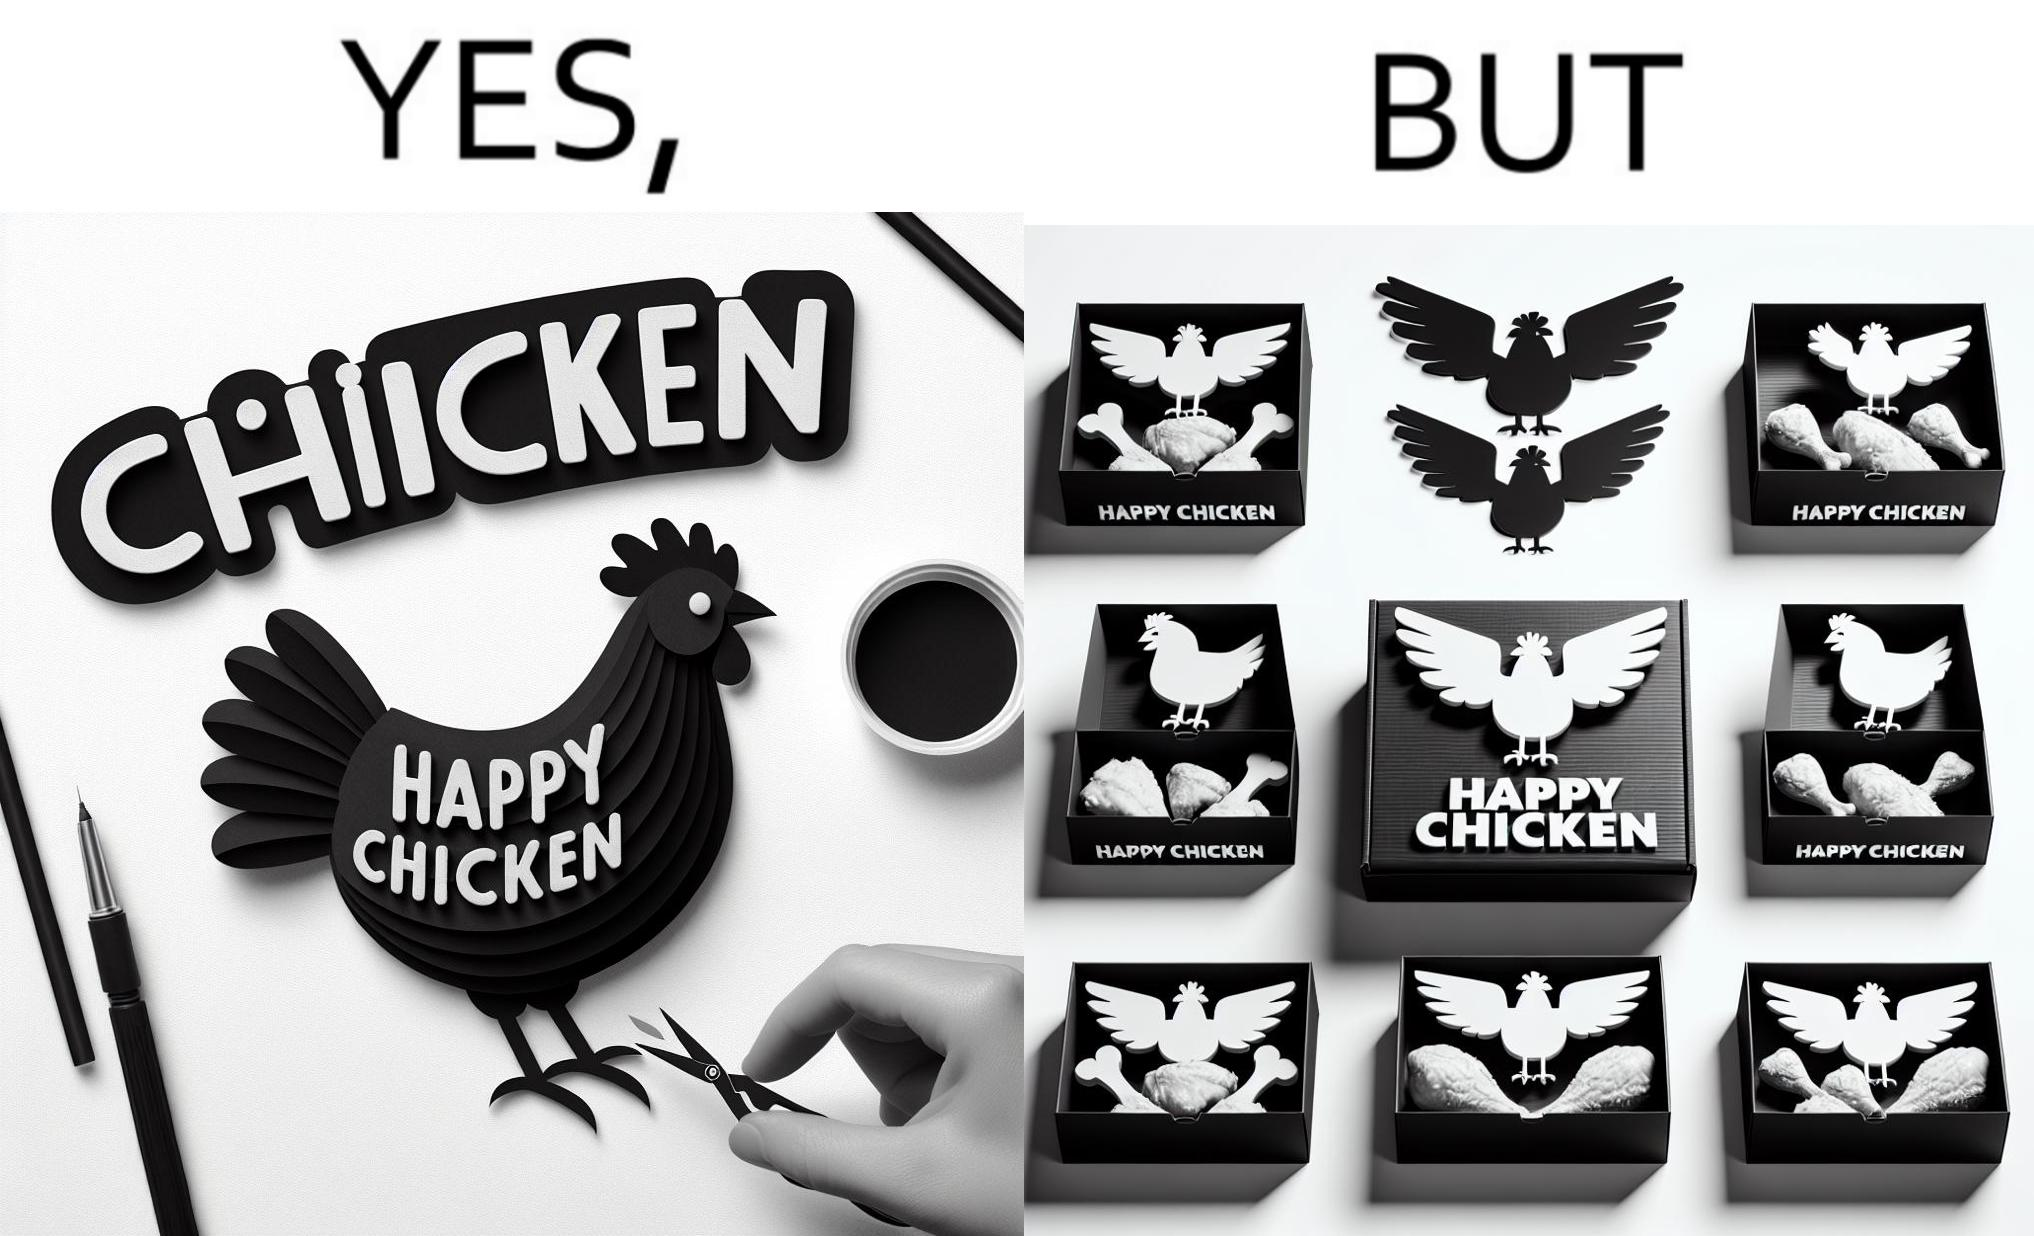What do you see in each half of this image? In the left part of the image: a chicken with a quote "HAPPY CHICKEN" in the background In the right part of the image: chicken pieces packed in boxes with a logo of a chicken with name "HAPPY CHICKEN" printed on it 